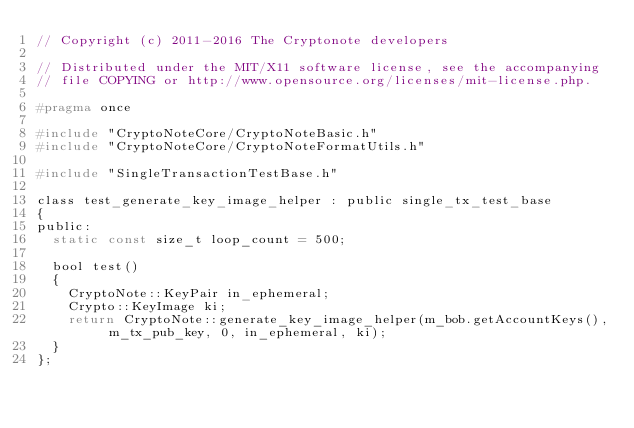<code> <loc_0><loc_0><loc_500><loc_500><_C_>// Copyright (c) 2011-2016 The Cryptonote developers
 
// Distributed under the MIT/X11 software license, see the accompanying
// file COPYING or http://www.opensource.org/licenses/mit-license.php.

#pragma once

#include "CryptoNoteCore/CryptoNoteBasic.h"
#include "CryptoNoteCore/CryptoNoteFormatUtils.h"

#include "SingleTransactionTestBase.h"

class test_generate_key_image_helper : public single_tx_test_base
{
public:
  static const size_t loop_count = 500;

  bool test()
  {
    CryptoNote::KeyPair in_ephemeral;
    Crypto::KeyImage ki;
    return CryptoNote::generate_key_image_helper(m_bob.getAccountKeys(), m_tx_pub_key, 0, in_ephemeral, ki);
  }
};
</code> 